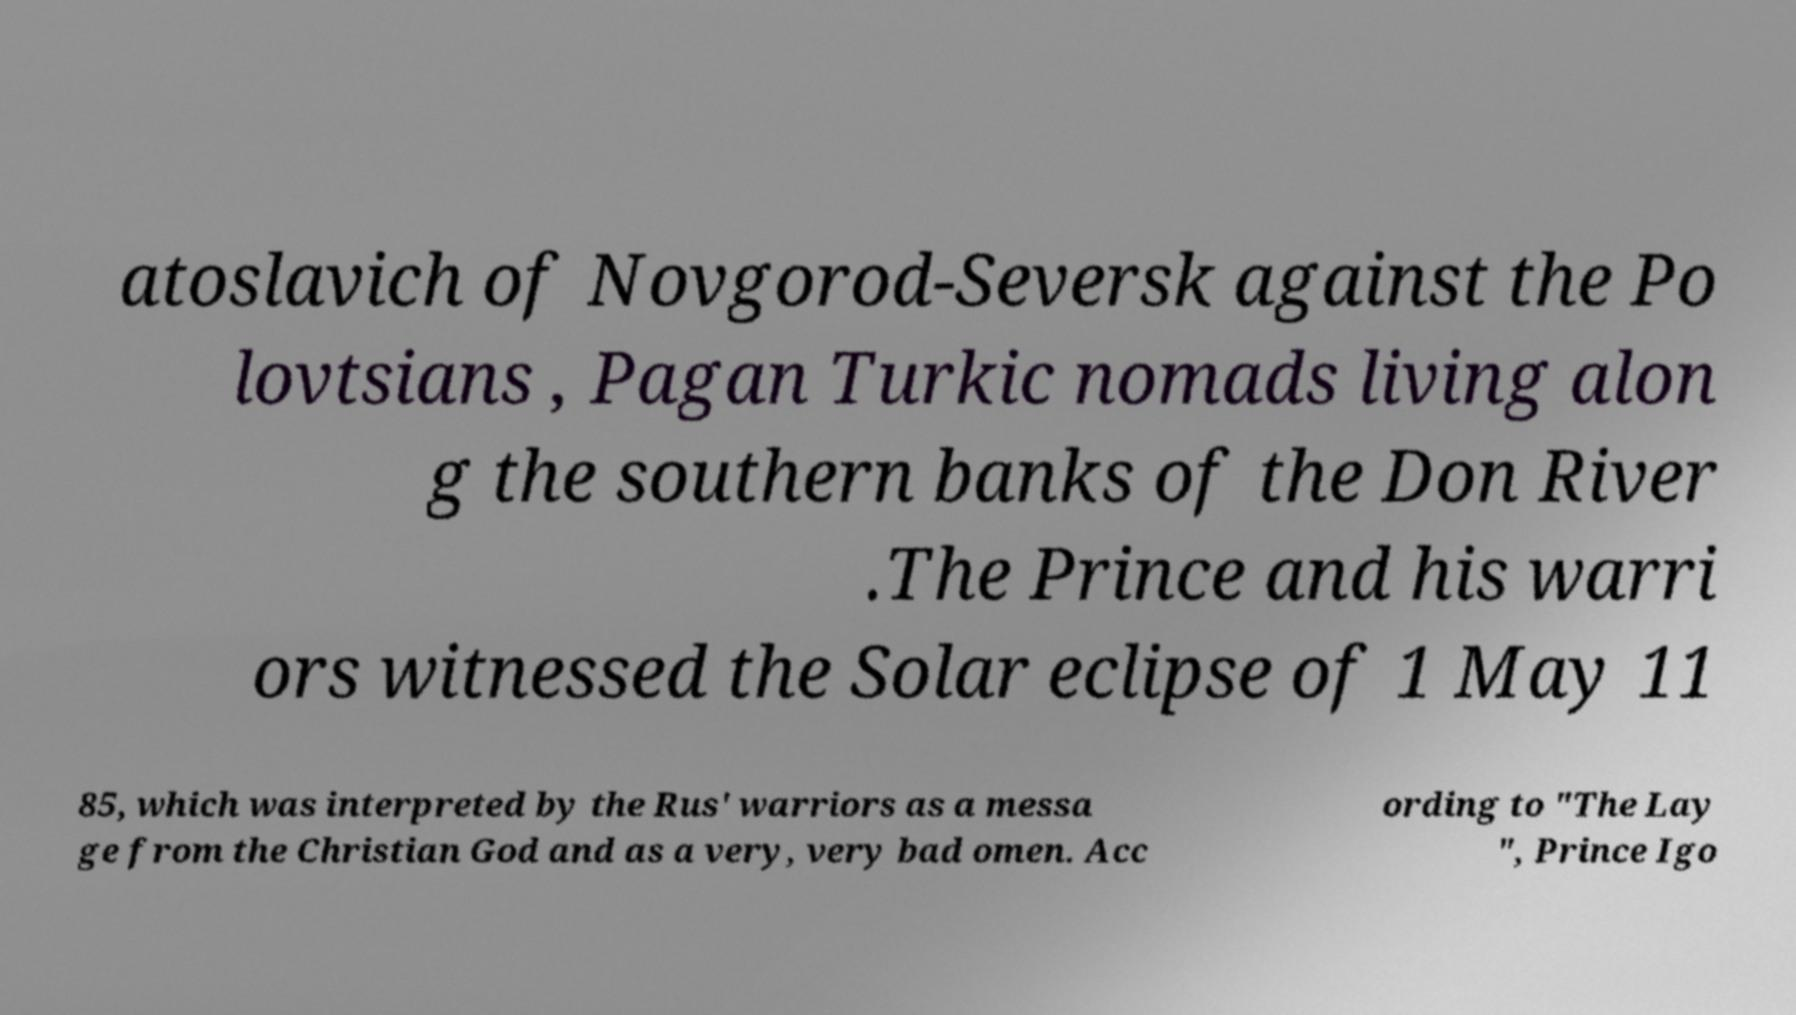What messages or text are displayed in this image? I need them in a readable, typed format. atoslavich of Novgorod-Seversk against the Po lovtsians , Pagan Turkic nomads living alon g the southern banks of the Don River .The Prince and his warri ors witnessed the Solar eclipse of 1 May 11 85, which was interpreted by the Rus' warriors as a messa ge from the Christian God and as a very, very bad omen. Acc ording to "The Lay ", Prince Igo 